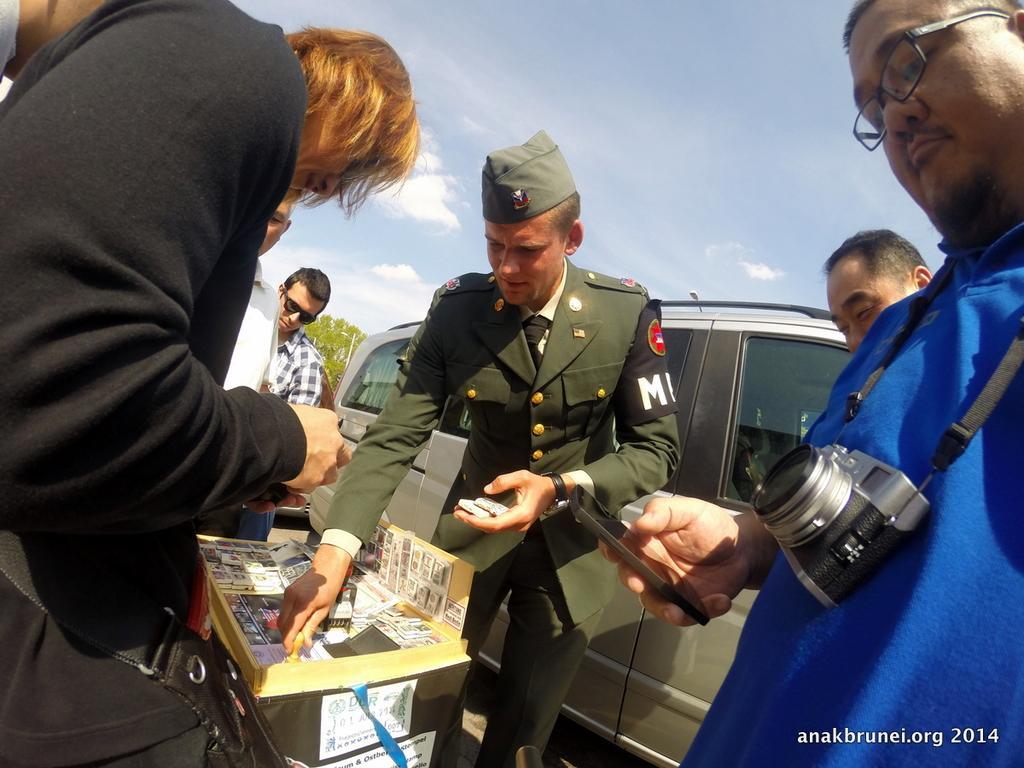In one or two sentences, can you explain what this image depicts? In this picture there is a person with blue t-shirt is standing and holding the device and there is a person with suit is standing and holding the object and there are group of people standing. There are objects on the box. At the back there is a vehicle and there is a tree. At the top there is sky and there are clouds. 